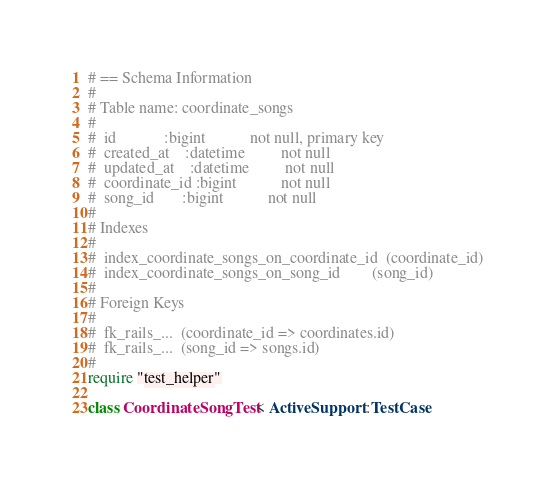Convert code to text. <code><loc_0><loc_0><loc_500><loc_500><_Ruby_># == Schema Information
#
# Table name: coordinate_songs
#
#  id            :bigint           not null, primary key
#  created_at    :datetime         not null
#  updated_at    :datetime         not null
#  coordinate_id :bigint           not null
#  song_id       :bigint           not null
#
# Indexes
#
#  index_coordinate_songs_on_coordinate_id  (coordinate_id)
#  index_coordinate_songs_on_song_id        (song_id)
#
# Foreign Keys
#
#  fk_rails_...  (coordinate_id => coordinates.id)
#  fk_rails_...  (song_id => songs.id)
#
require "test_helper"

class CoordinateSongTest < ActiveSupport::TestCase</code> 